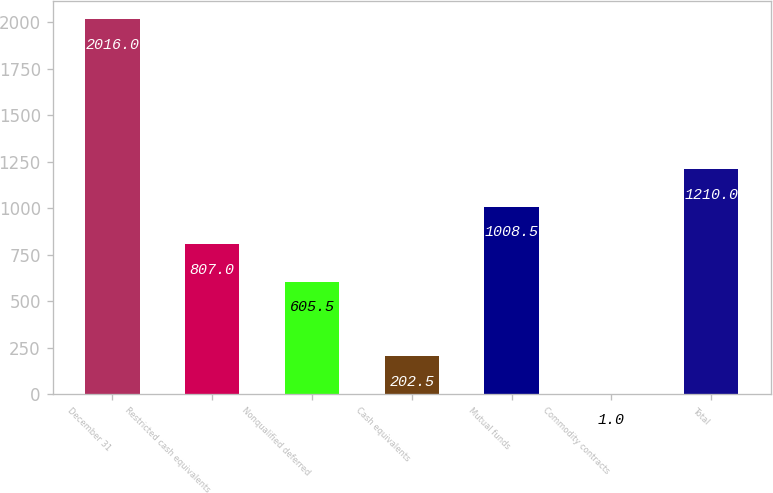<chart> <loc_0><loc_0><loc_500><loc_500><bar_chart><fcel>December 31<fcel>Restricted cash equivalents<fcel>Nonqualified deferred<fcel>Cash equivalents<fcel>Mutual funds<fcel>Commodity contracts<fcel>Total<nl><fcel>2016<fcel>807<fcel>605.5<fcel>202.5<fcel>1008.5<fcel>1<fcel>1210<nl></chart> 